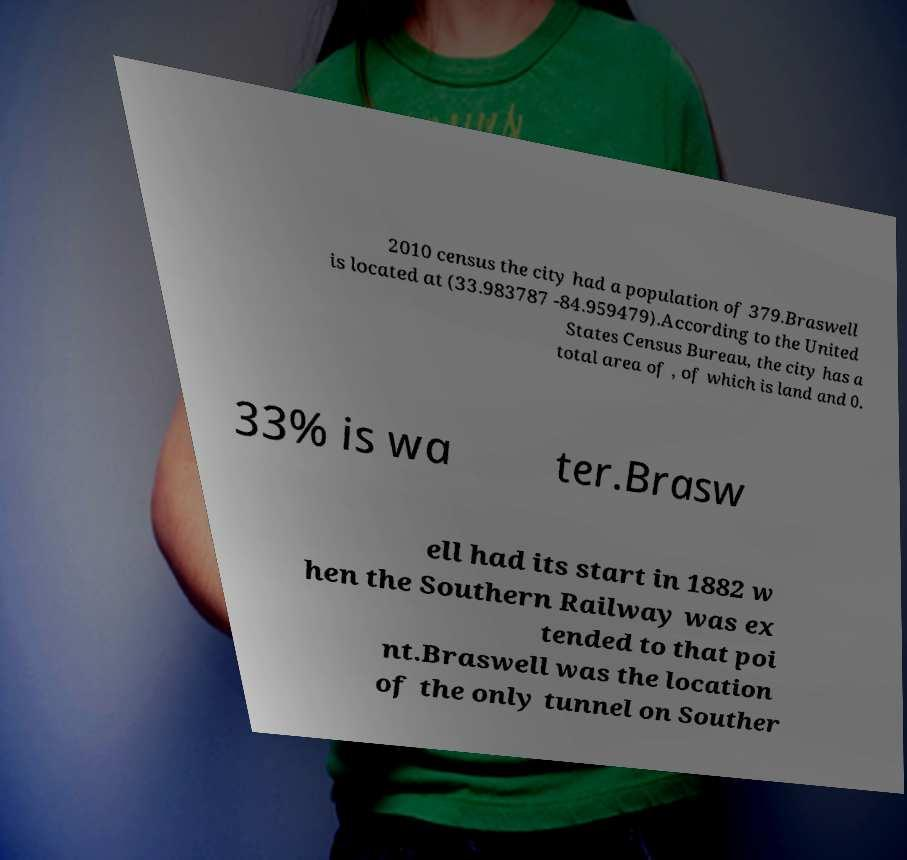Can you accurately transcribe the text from the provided image for me? 2010 census the city had a population of 379.Braswell is located at (33.983787 -84.959479).According to the United States Census Bureau, the city has a total area of , of which is land and 0. 33% is wa ter.Brasw ell had its start in 1882 w hen the Southern Railway was ex tended to that poi nt.Braswell was the location of the only tunnel on Souther 